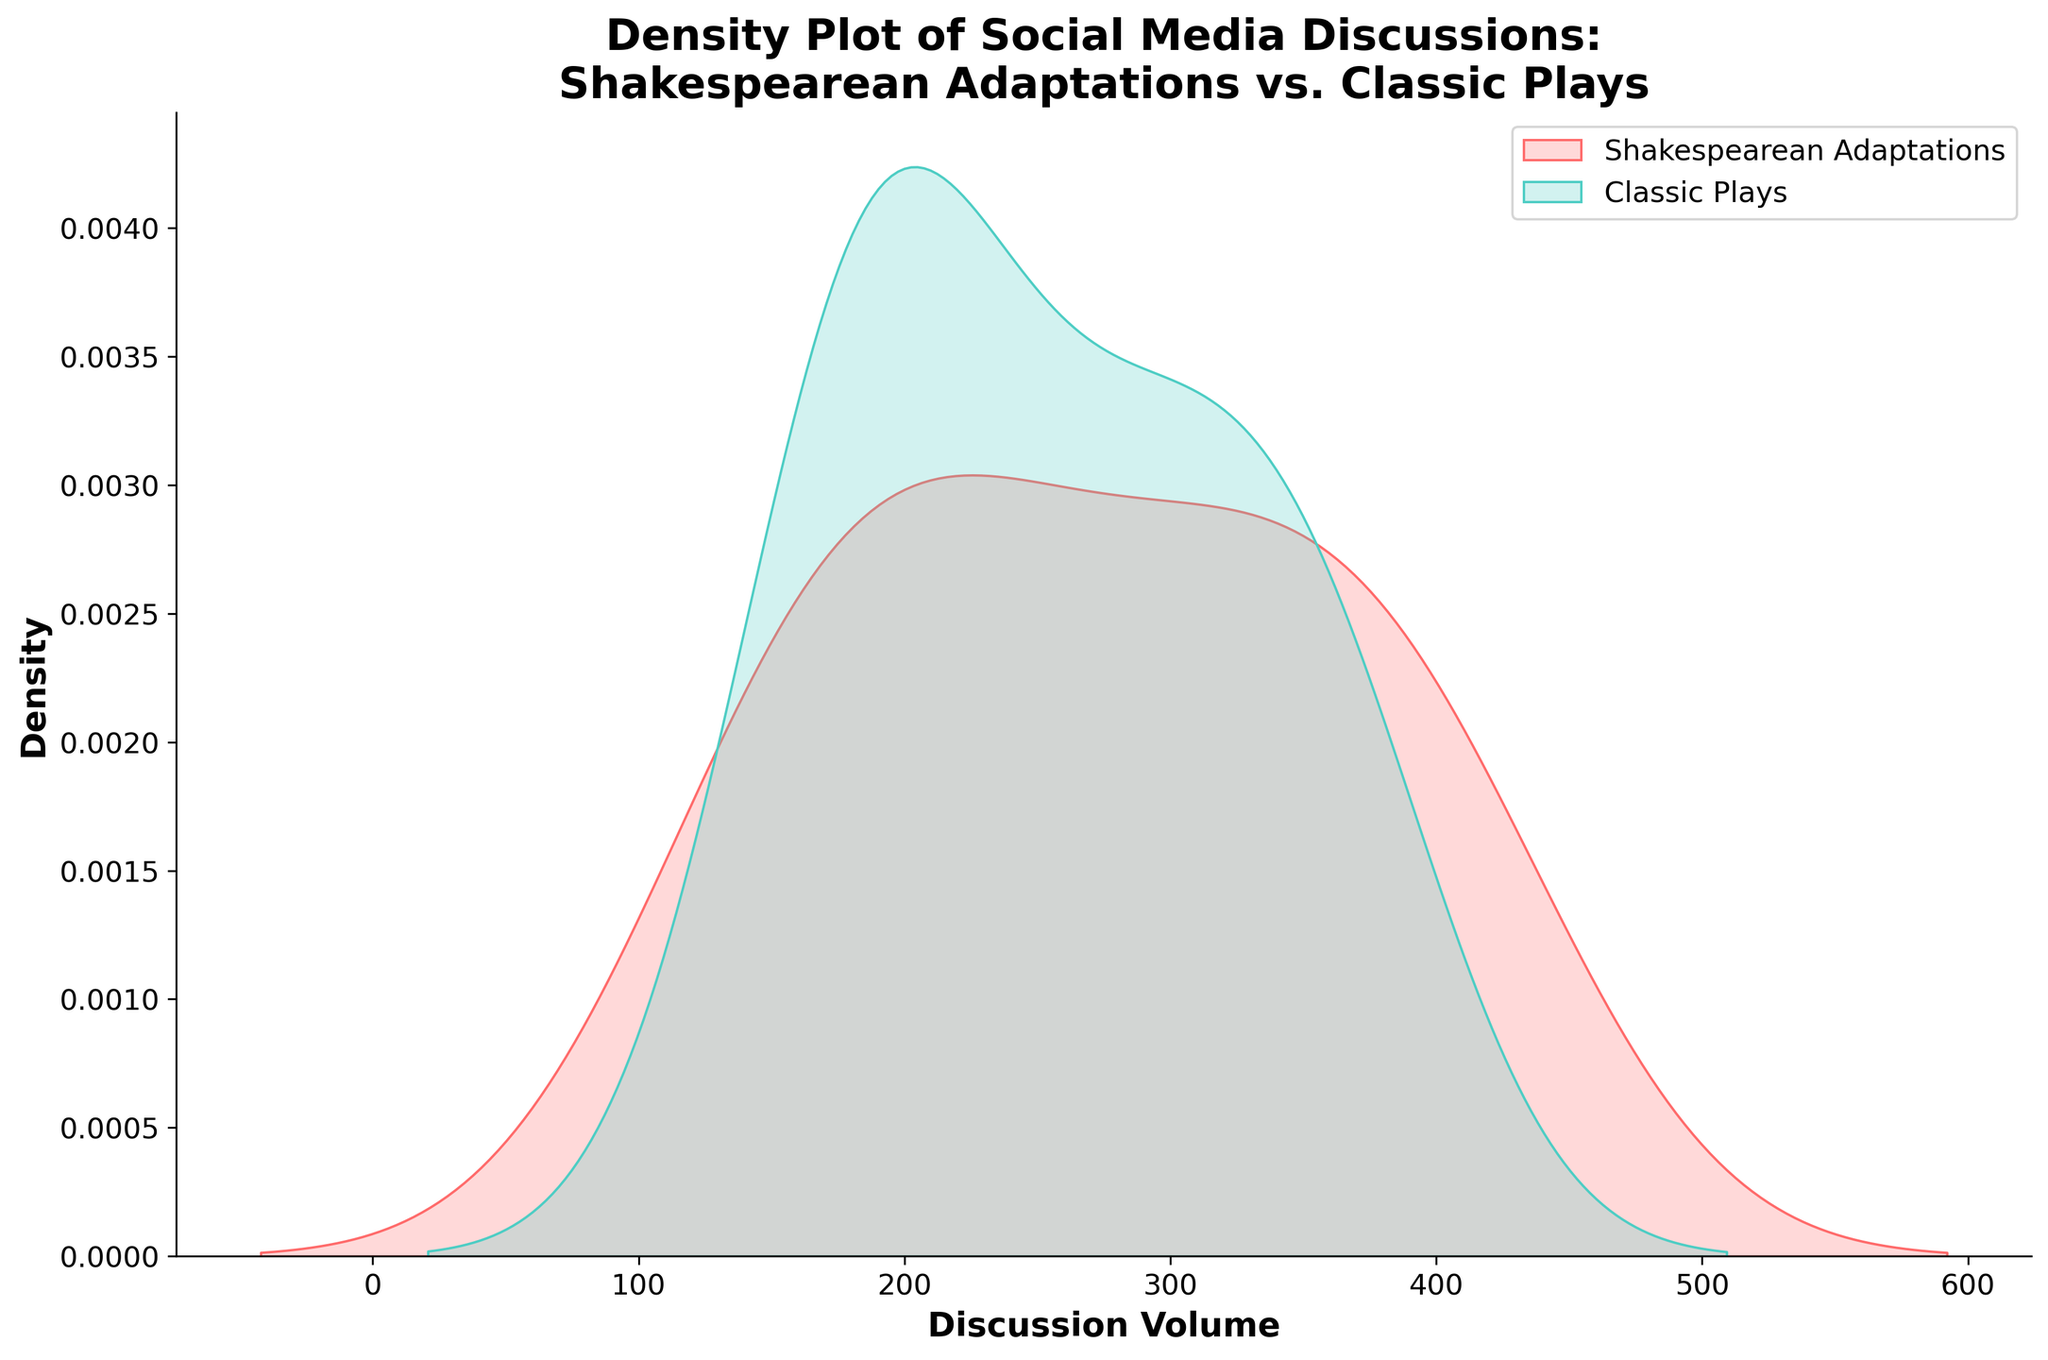What is the title of the plot? The title is usually placed at the top of the plot and summarizes the visual content. Here, it reads "Density Plot of Social Media Discussions: Shakespearean Adaptations vs. Classic Plays".
Answer: Density Plot of Social Media Discussions: Shakespearean Adaptations vs. Classic Plays What does the x-axis represent in the plot? The x-axis typically represents the variable being measured. In this plot, the x-axis is labeled 'Discussion Volume', indicating the volume of discussions on social media.
Answer: Discussion Volume What are the colors used to represent Shakespearean Adaptations and Classic Plays in the plot? The colors used to represent these categories are usually indicated in the legend. Here, Shakespearean Adaptations are represented in a reddish hue, while Classic Plays are in a teal color.
Answer: Red for Shakespearean Adaptations and teal for Classic Plays Which type of social media discussion has a higher peak density? To determine which group has a higher peak density, look for the peak of the shaded area on the y-axis. The plot should indicate that Shakespearean Adaptations have a slightly higher peak.
Answer: Shakespearean Adaptations How are the distributions of Shakespearean Adaptations and Classic Plays compared? By examining the density shapes and the spread of the shaded areas, we can compare how the discussion volumes are distributed for both types across social media. Shakespearean Adaptations have a more concentrated peak compared to Classic Plays, which indicates a difference in distribution characteristics.
Answer: Shakespearean Adaptations are more concentrated; Classic Plays are more spread out At what discussion volume do Shakespearean Adaptations and Classic Plays have the highest density? This involves identifying the x-values where the density curves reach their maximum points. The plot shows that the highest density for both occurs around the same discussion volume, close to 300-320.
Answer: 300-320 Which type of social media discussion shows more variability in discussion volume? Variability can be inferred from the width of the density plot. Classic Plays show more variability due to a broader curve, indicating a wider range of discussion volumes.
Answer: Classic Plays Where does the density of Classic Plays rapidly decline? Observing where the slope of the density curve sharply falls can indicate a rapid decline. For Classic Plays, a sharp decrease happens around a discussion volume of 350.
Answer: Around 350 Does either type of social media discussion show a bimodal distribution? A bimodal distribution would show two distinct peaks in the density curve. By examining the curves, we can see Classic Plays have a slight bimodal tendency around 200 and 320, whereas Shakespearean Adaptations do not.
Answer: Classic Plays What can you infer about the overall popularity of Shakespearean Adaptations versus Classic Plays on social media? Considering the density and distribution, we infer that both have peaks around similar volumes, but Shakespearean Adaptations tend to have more consistently high discussion volumes, whereas Classic Plays have a broader distribution.
Answer: Shakespearean Adaptations are consistently popular; Classic Plays have varied popularity 